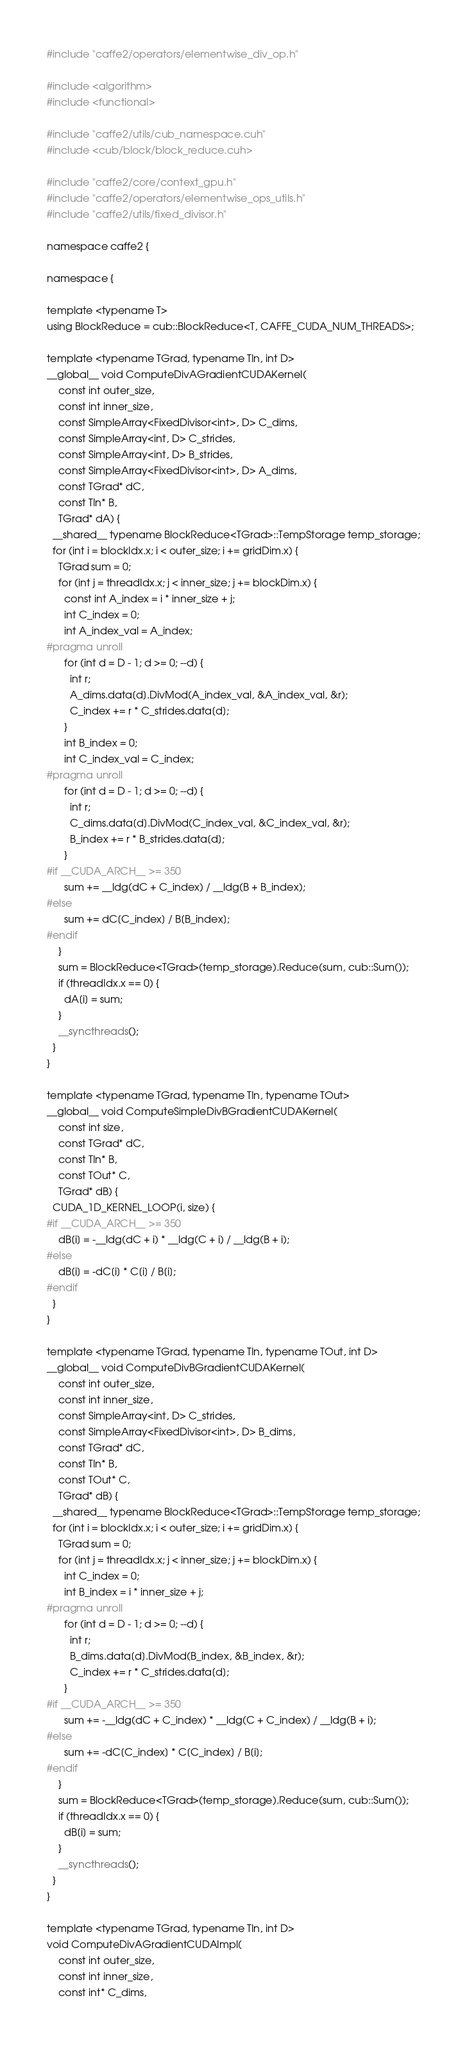Convert code to text. <code><loc_0><loc_0><loc_500><loc_500><_Cuda_>#include "caffe2/operators/elementwise_div_op.h"

#include <algorithm>
#include <functional>

#include "caffe2/utils/cub_namespace.cuh"
#include <cub/block/block_reduce.cuh>

#include "caffe2/core/context_gpu.h"
#include "caffe2/operators/elementwise_ops_utils.h"
#include "caffe2/utils/fixed_divisor.h"

namespace caffe2 {

namespace {

template <typename T>
using BlockReduce = cub::BlockReduce<T, CAFFE_CUDA_NUM_THREADS>;

template <typename TGrad, typename TIn, int D>
__global__ void ComputeDivAGradientCUDAKernel(
    const int outer_size,
    const int inner_size,
    const SimpleArray<FixedDivisor<int>, D> C_dims,
    const SimpleArray<int, D> C_strides,
    const SimpleArray<int, D> B_strides,
    const SimpleArray<FixedDivisor<int>, D> A_dims,
    const TGrad* dC,
    const TIn* B,
    TGrad* dA) {
  __shared__ typename BlockReduce<TGrad>::TempStorage temp_storage;
  for (int i = blockIdx.x; i < outer_size; i += gridDim.x) {
    TGrad sum = 0;
    for (int j = threadIdx.x; j < inner_size; j += blockDim.x) {
      const int A_index = i * inner_size + j;
      int C_index = 0;
      int A_index_val = A_index;
#pragma unroll
      for (int d = D - 1; d >= 0; --d) {
        int r;
        A_dims.data[d].DivMod(A_index_val, &A_index_val, &r);
        C_index += r * C_strides.data[d];
      }
      int B_index = 0;
      int C_index_val = C_index;
#pragma unroll
      for (int d = D - 1; d >= 0; --d) {
        int r;
        C_dims.data[d].DivMod(C_index_val, &C_index_val, &r);
        B_index += r * B_strides.data[d];
      }
#if __CUDA_ARCH__ >= 350
      sum += __ldg(dC + C_index) / __ldg(B + B_index);
#else
      sum += dC[C_index] / B[B_index];
#endif
    }
    sum = BlockReduce<TGrad>(temp_storage).Reduce(sum, cub::Sum());
    if (threadIdx.x == 0) {
      dA[i] = sum;
    }
    __syncthreads();
  }
}

template <typename TGrad, typename TIn, typename TOut>
__global__ void ComputeSimpleDivBGradientCUDAKernel(
    const int size,
    const TGrad* dC,
    const TIn* B,
    const TOut* C,
    TGrad* dB) {
  CUDA_1D_KERNEL_LOOP(i, size) {
#if __CUDA_ARCH__ >= 350
    dB[i] = -__ldg(dC + i) * __ldg(C + i) / __ldg(B + i);
#else
    dB[i] = -dC[i] * C[i] / B[i];
#endif
  }
}

template <typename TGrad, typename TIn, typename TOut, int D>
__global__ void ComputeDivBGradientCUDAKernel(
    const int outer_size,
    const int inner_size,
    const SimpleArray<int, D> C_strides,
    const SimpleArray<FixedDivisor<int>, D> B_dims,
    const TGrad* dC,
    const TIn* B,
    const TOut* C,
    TGrad* dB) {
  __shared__ typename BlockReduce<TGrad>::TempStorage temp_storage;
  for (int i = blockIdx.x; i < outer_size; i += gridDim.x) {
    TGrad sum = 0;
    for (int j = threadIdx.x; j < inner_size; j += blockDim.x) {
      int C_index = 0;
      int B_index = i * inner_size + j;
#pragma unroll
      for (int d = D - 1; d >= 0; --d) {
        int r;
        B_dims.data[d].DivMod(B_index, &B_index, &r);
        C_index += r * C_strides.data[d];
      }
#if __CUDA_ARCH__ >= 350
      sum += -__ldg(dC + C_index) * __ldg(C + C_index) / __ldg(B + i);
#else
      sum += -dC[C_index] * C[C_index] / B[i];
#endif
    }
    sum = BlockReduce<TGrad>(temp_storage).Reduce(sum, cub::Sum());
    if (threadIdx.x == 0) {
      dB[i] = sum;
    }
    __syncthreads();
  }
}

template <typename TGrad, typename TIn, int D>
void ComputeDivAGradientCUDAImpl(
    const int outer_size,
    const int inner_size,
    const int* C_dims,</code> 